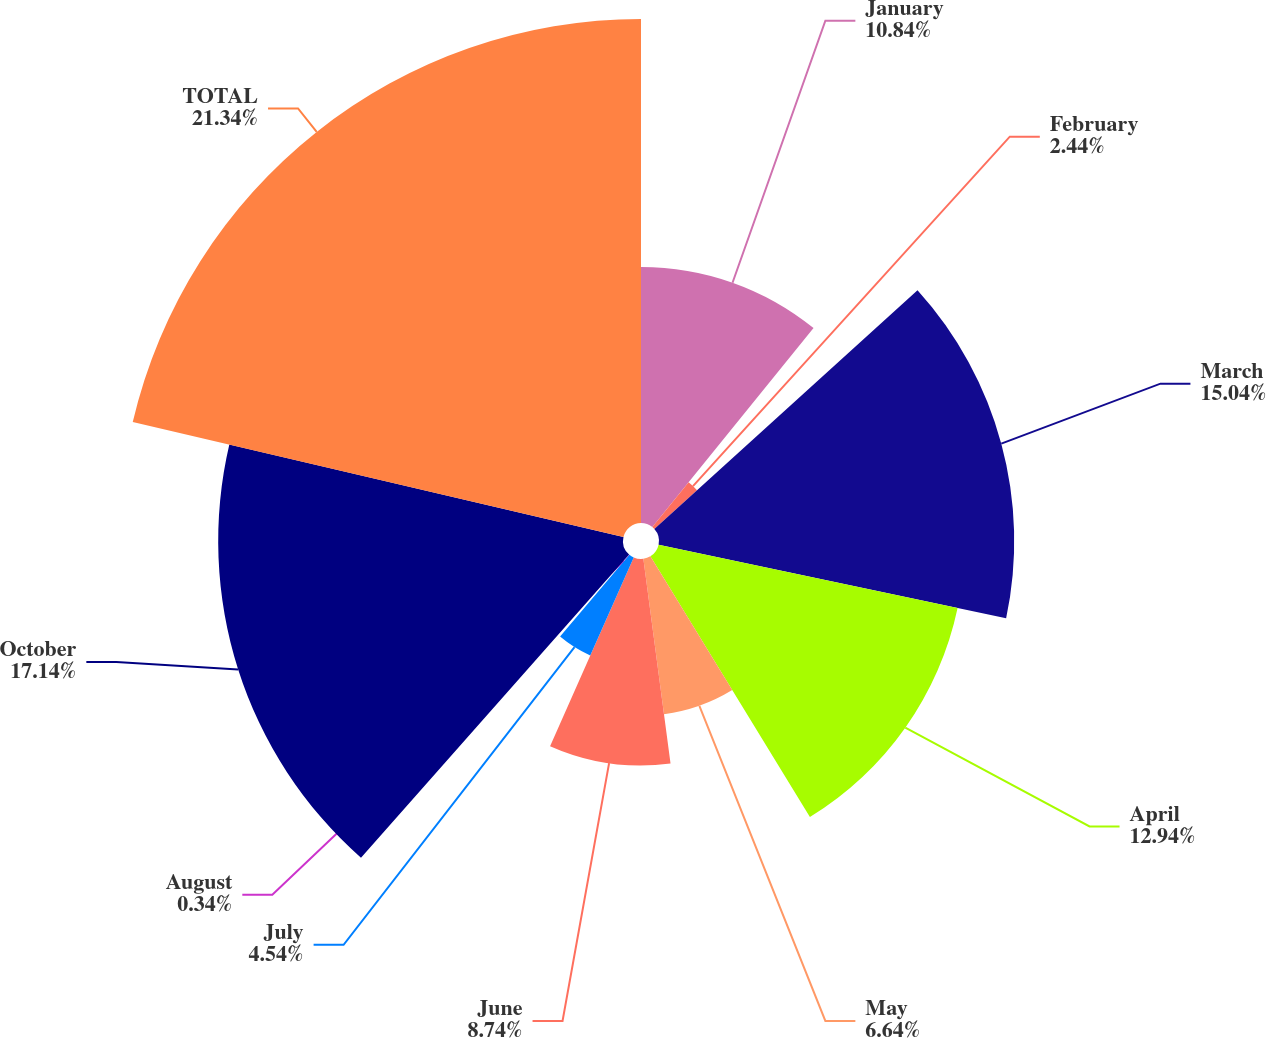Convert chart. <chart><loc_0><loc_0><loc_500><loc_500><pie_chart><fcel>January<fcel>February<fcel>March<fcel>April<fcel>May<fcel>June<fcel>July<fcel>August<fcel>October<fcel>TOTAL<nl><fcel>10.84%<fcel>2.44%<fcel>15.04%<fcel>12.94%<fcel>6.64%<fcel>8.74%<fcel>4.54%<fcel>0.34%<fcel>17.14%<fcel>21.34%<nl></chart> 